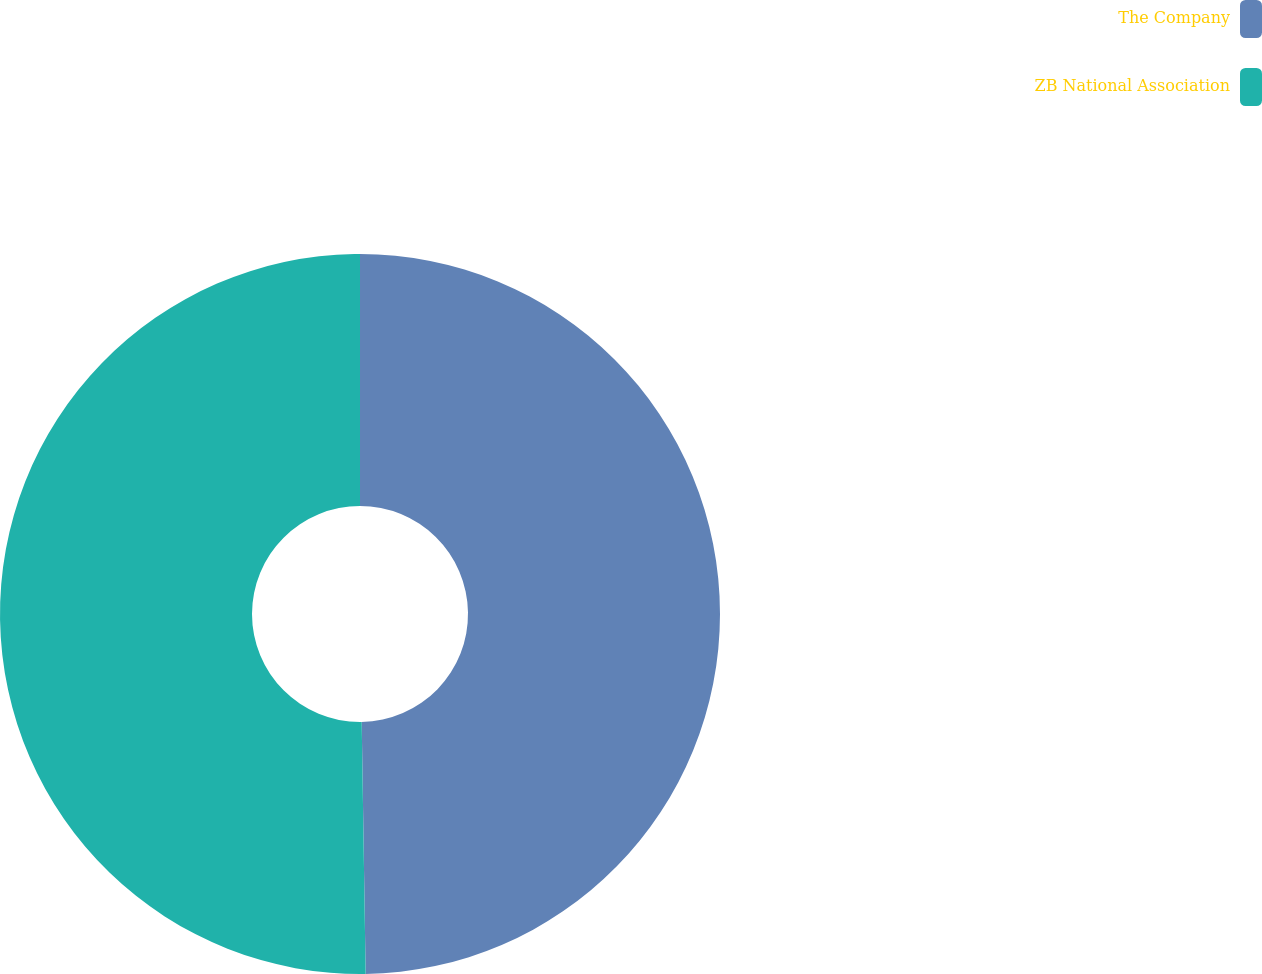Convert chart to OTSL. <chart><loc_0><loc_0><loc_500><loc_500><pie_chart><fcel>The Company<fcel>ZB National Association<nl><fcel>49.75%<fcel>50.25%<nl></chart> 